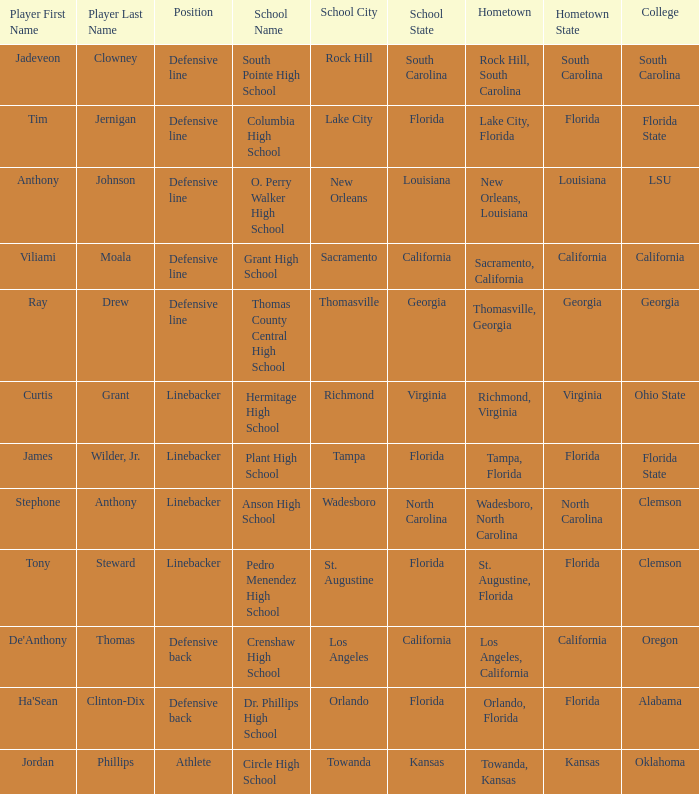What college has a position of defensive line and Grant high school? California. 